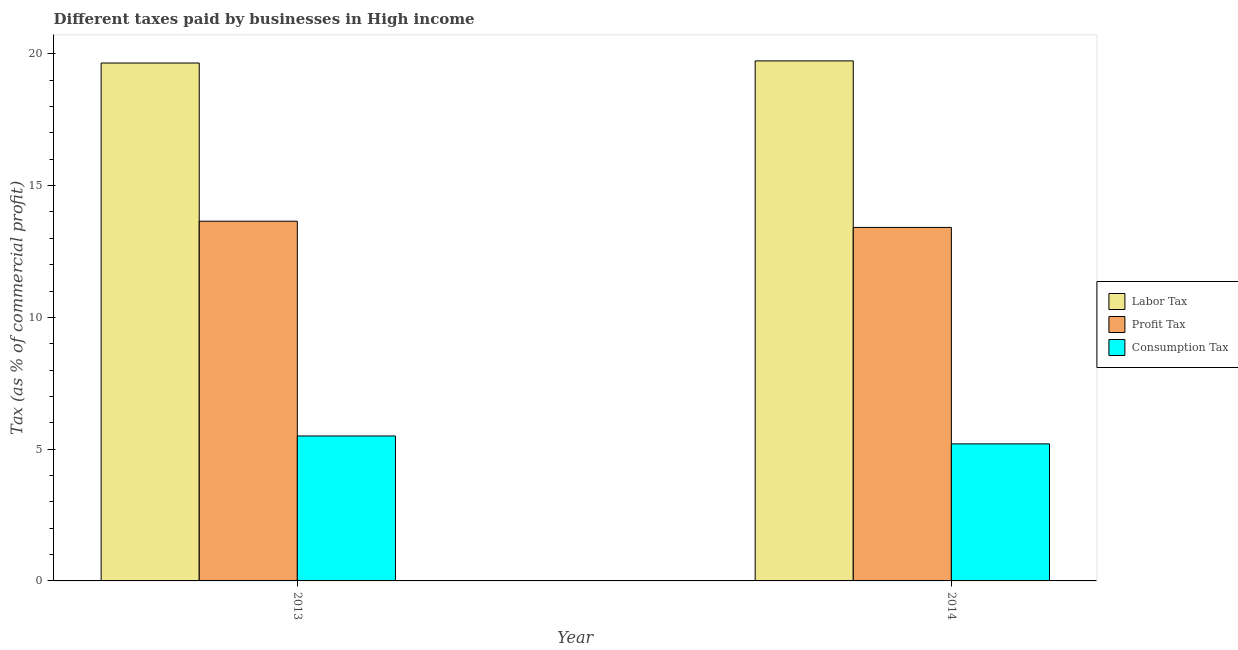How many different coloured bars are there?
Offer a terse response. 3. How many groups of bars are there?
Offer a very short reply. 2. Are the number of bars per tick equal to the number of legend labels?
Ensure brevity in your answer.  Yes. Are the number of bars on each tick of the X-axis equal?
Make the answer very short. Yes. How many bars are there on the 1st tick from the left?
Keep it short and to the point. 3. What is the label of the 2nd group of bars from the left?
Offer a terse response. 2014. What is the percentage of labor tax in 2014?
Your answer should be compact. 19.73. Across all years, what is the maximum percentage of consumption tax?
Offer a very short reply. 5.5. Across all years, what is the minimum percentage of profit tax?
Your response must be concise. 13.41. What is the total percentage of profit tax in the graph?
Offer a very short reply. 27.06. What is the difference between the percentage of labor tax in 2013 and that in 2014?
Provide a short and direct response. -0.08. What is the difference between the percentage of consumption tax in 2013 and the percentage of labor tax in 2014?
Offer a very short reply. 0.3. What is the average percentage of labor tax per year?
Give a very brief answer. 19.69. In how many years, is the percentage of consumption tax greater than 7 %?
Your response must be concise. 0. What is the ratio of the percentage of consumption tax in 2013 to that in 2014?
Provide a short and direct response. 1.06. Is the percentage of labor tax in 2013 less than that in 2014?
Keep it short and to the point. Yes. In how many years, is the percentage of labor tax greater than the average percentage of labor tax taken over all years?
Your answer should be compact. 1. What does the 2nd bar from the left in 2013 represents?
Offer a terse response. Profit Tax. What does the 1st bar from the right in 2013 represents?
Your response must be concise. Consumption Tax. Is it the case that in every year, the sum of the percentage of labor tax and percentage of profit tax is greater than the percentage of consumption tax?
Make the answer very short. Yes. How many bars are there?
Provide a short and direct response. 6. How many years are there in the graph?
Offer a terse response. 2. What is the difference between two consecutive major ticks on the Y-axis?
Your answer should be very brief. 5. Does the graph contain any zero values?
Give a very brief answer. No. Does the graph contain grids?
Keep it short and to the point. No. How are the legend labels stacked?
Offer a terse response. Vertical. What is the title of the graph?
Your answer should be compact. Different taxes paid by businesses in High income. What is the label or title of the Y-axis?
Provide a short and direct response. Tax (as % of commercial profit). What is the Tax (as % of commercial profit) in Labor Tax in 2013?
Provide a succinct answer. 19.65. What is the Tax (as % of commercial profit) in Profit Tax in 2013?
Offer a very short reply. 13.65. What is the Tax (as % of commercial profit) in Labor Tax in 2014?
Offer a very short reply. 19.73. What is the Tax (as % of commercial profit) of Profit Tax in 2014?
Give a very brief answer. 13.41. What is the Tax (as % of commercial profit) in Consumption Tax in 2014?
Ensure brevity in your answer.  5.2. Across all years, what is the maximum Tax (as % of commercial profit) of Labor Tax?
Your answer should be compact. 19.73. Across all years, what is the maximum Tax (as % of commercial profit) of Profit Tax?
Your answer should be compact. 13.65. Across all years, what is the maximum Tax (as % of commercial profit) in Consumption Tax?
Provide a short and direct response. 5.5. Across all years, what is the minimum Tax (as % of commercial profit) of Labor Tax?
Offer a very short reply. 19.65. Across all years, what is the minimum Tax (as % of commercial profit) of Profit Tax?
Give a very brief answer. 13.41. What is the total Tax (as % of commercial profit) in Labor Tax in the graph?
Keep it short and to the point. 39.38. What is the total Tax (as % of commercial profit) in Profit Tax in the graph?
Provide a short and direct response. 27.06. What is the difference between the Tax (as % of commercial profit) in Labor Tax in 2013 and that in 2014?
Offer a very short reply. -0.08. What is the difference between the Tax (as % of commercial profit) in Profit Tax in 2013 and that in 2014?
Provide a short and direct response. 0.24. What is the difference between the Tax (as % of commercial profit) in Labor Tax in 2013 and the Tax (as % of commercial profit) in Profit Tax in 2014?
Offer a terse response. 6.24. What is the difference between the Tax (as % of commercial profit) of Labor Tax in 2013 and the Tax (as % of commercial profit) of Consumption Tax in 2014?
Offer a very short reply. 14.45. What is the difference between the Tax (as % of commercial profit) in Profit Tax in 2013 and the Tax (as % of commercial profit) in Consumption Tax in 2014?
Ensure brevity in your answer.  8.45. What is the average Tax (as % of commercial profit) of Labor Tax per year?
Your answer should be very brief. 19.69. What is the average Tax (as % of commercial profit) in Profit Tax per year?
Offer a very short reply. 13.53. What is the average Tax (as % of commercial profit) of Consumption Tax per year?
Offer a terse response. 5.35. In the year 2013, what is the difference between the Tax (as % of commercial profit) of Labor Tax and Tax (as % of commercial profit) of Profit Tax?
Provide a succinct answer. 6. In the year 2013, what is the difference between the Tax (as % of commercial profit) of Labor Tax and Tax (as % of commercial profit) of Consumption Tax?
Give a very brief answer. 14.15. In the year 2013, what is the difference between the Tax (as % of commercial profit) of Profit Tax and Tax (as % of commercial profit) of Consumption Tax?
Offer a very short reply. 8.15. In the year 2014, what is the difference between the Tax (as % of commercial profit) of Labor Tax and Tax (as % of commercial profit) of Profit Tax?
Make the answer very short. 6.32. In the year 2014, what is the difference between the Tax (as % of commercial profit) of Labor Tax and Tax (as % of commercial profit) of Consumption Tax?
Your answer should be compact. 14.53. In the year 2014, what is the difference between the Tax (as % of commercial profit) of Profit Tax and Tax (as % of commercial profit) of Consumption Tax?
Provide a short and direct response. 8.21. What is the ratio of the Tax (as % of commercial profit) in Labor Tax in 2013 to that in 2014?
Your answer should be compact. 1. What is the ratio of the Tax (as % of commercial profit) of Profit Tax in 2013 to that in 2014?
Your answer should be compact. 1.02. What is the ratio of the Tax (as % of commercial profit) of Consumption Tax in 2013 to that in 2014?
Offer a very short reply. 1.06. What is the difference between the highest and the second highest Tax (as % of commercial profit) in Labor Tax?
Give a very brief answer. 0.08. What is the difference between the highest and the second highest Tax (as % of commercial profit) in Profit Tax?
Offer a terse response. 0.24. What is the difference between the highest and the lowest Tax (as % of commercial profit) in Labor Tax?
Ensure brevity in your answer.  0.08. What is the difference between the highest and the lowest Tax (as % of commercial profit) in Profit Tax?
Your response must be concise. 0.24. 